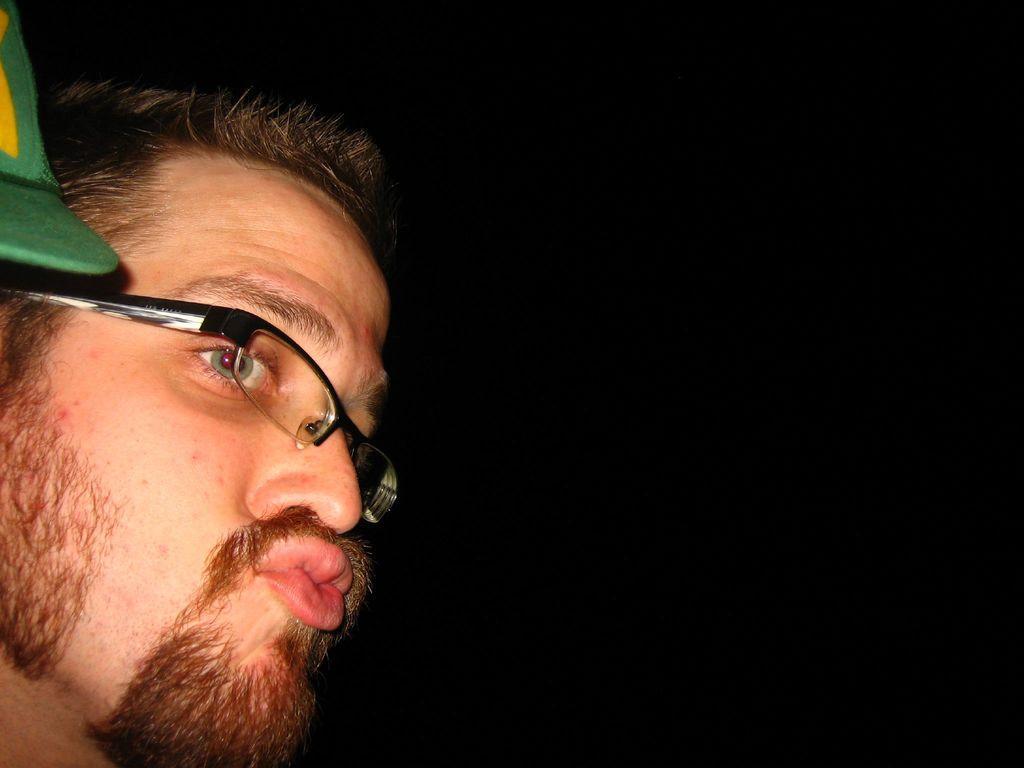Can you describe this image briefly? In this image we can see a man wearing glasses. 